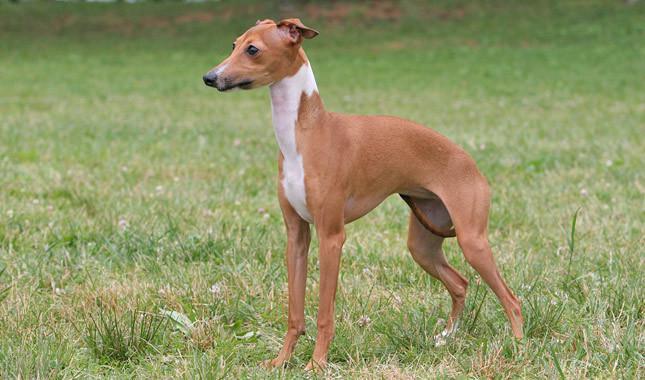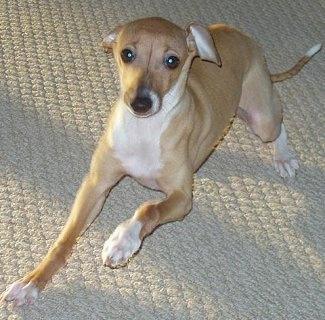The first image is the image on the left, the second image is the image on the right. For the images shown, is this caption "Three dogs are posing together in one of the images." true? Answer yes or no. No. The first image is the image on the left, the second image is the image on the right. For the images shown, is this caption "One image shows one hound wearing attire besides a collar, and the other image shows at least one dog wearing just a collar." true? Answer yes or no. No. 